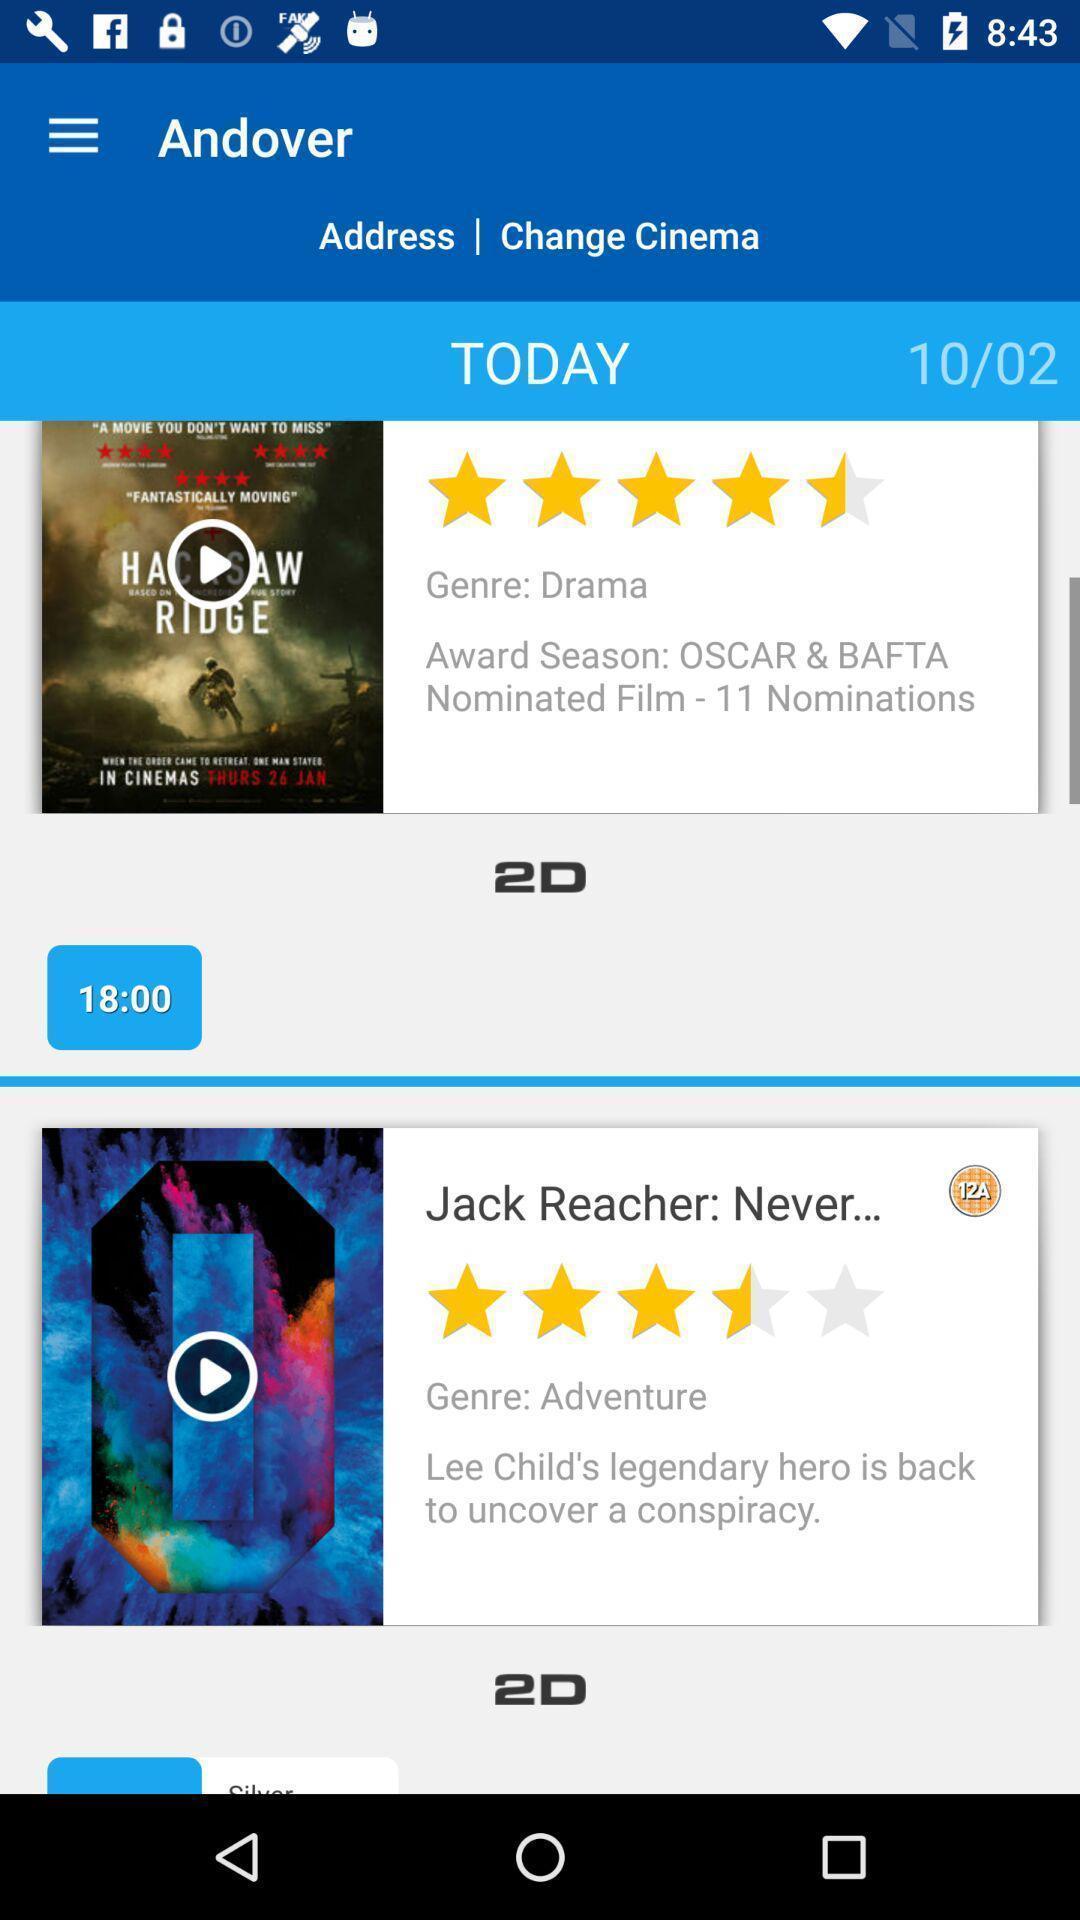Summarize the information in this screenshot. Screen displaying the movies in a ticket booking app. 